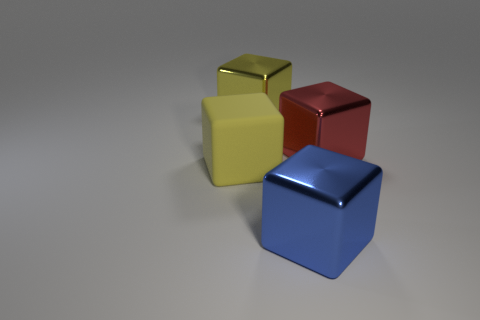There is a yellow block in front of the big red shiny object; is its size the same as the metal thing on the right side of the large blue metal cube?
Keep it short and to the point. Yes. There is a cube that is to the left of the large metallic thing on the left side of the large blue object; what is its color?
Offer a very short reply. Yellow. There is a red thing that is the same size as the blue cube; what is it made of?
Offer a very short reply. Metal. How many rubber things are either big cubes or small cyan cylinders?
Your response must be concise. 1. What is the color of the big metal cube that is both behind the big matte object and left of the red block?
Your answer should be very brief. Yellow. There is a blue metal block; how many big red metallic things are left of it?
Give a very brief answer. 0. What is the material of the red block?
Keep it short and to the point. Metal. What color is the large metallic cube that is in front of the large yellow cube in front of the large yellow cube that is behind the large matte cube?
Keep it short and to the point. Blue. What number of blue shiny objects have the same size as the blue shiny block?
Give a very brief answer. 0. There is a shiny thing that is left of the blue thing; what color is it?
Your answer should be compact. Yellow. 